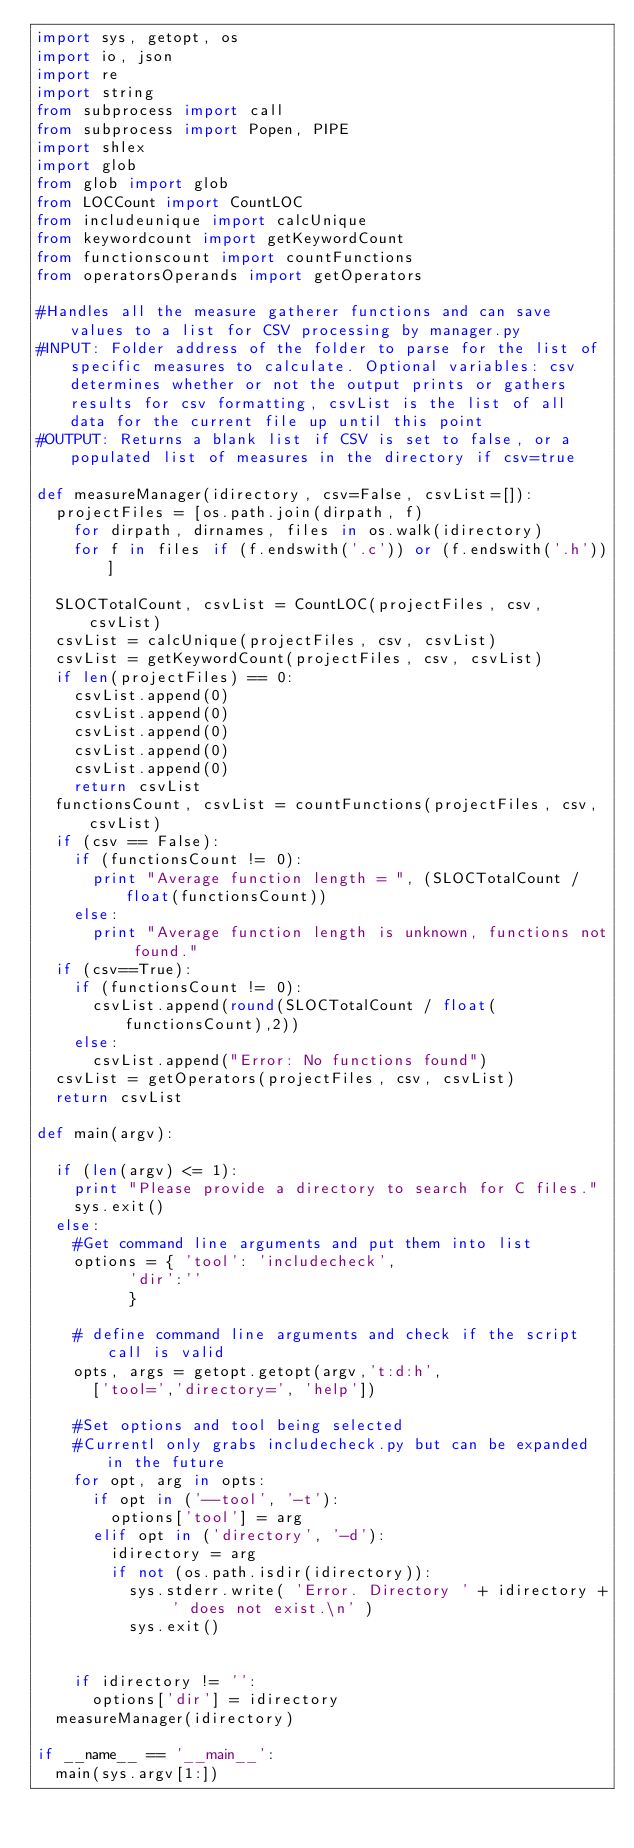Convert code to text. <code><loc_0><loc_0><loc_500><loc_500><_Python_>import sys, getopt, os
import io, json
import re
import string
from subprocess import call
from subprocess import Popen, PIPE
import shlex
import glob
from glob import glob
from LOCCount import CountLOC
from includeunique import calcUnique
from keywordcount import getKeywordCount
from functionscount import countFunctions
from operatorsOperands import getOperators

#Handles all the measure gatherer functions and can save values to a list for CSV processing by manager.py
#INPUT: Folder address of the folder to parse for the list of specific measures to calculate. Optional variables: csv determines whether or not the output prints or gathers results for csv formatting, csvList is the list of all data for the current file up until this point
#OUTPUT: Returns a blank list if CSV is set to false, or a populated list of measures in the directory if csv=true

def measureManager(idirectory, csv=False, csvList=[]):
	projectFiles = [os.path.join(dirpath, f)
		for dirpath, dirnames, files in os.walk(idirectory)
		for f in files if (f.endswith('.c')) or (f.endswith('.h'))]

	SLOCTotalCount, csvList = CountLOC(projectFiles, csv, csvList)
	csvList = calcUnique(projectFiles, csv, csvList)
	csvList = getKeywordCount(projectFiles, csv, csvList)
	if len(projectFiles) == 0:
		csvList.append(0)
		csvList.append(0)
		csvList.append(0)
		csvList.append(0)
		csvList.append(0)
		return csvList
	functionsCount, csvList = countFunctions(projectFiles, csv, csvList)
	if (csv == False):
		if (functionsCount != 0):
			print "Average function length = ", (SLOCTotalCount / float(functionsCount))
		else:
			print "Average function length is unknown, functions not found."
	if (csv==True):
		if (functionsCount != 0):
			csvList.append(round(SLOCTotalCount / float(functionsCount),2))
		else:
			csvList.append("Error: No functions found")
	csvList = getOperators(projectFiles, csv, csvList)
	return csvList

def main(argv):
	
	if (len(argv) <= 1):
		print "Please provide a directory to search for C files."
		sys.exit()
	else:
		#Get command line arguments and put them into list
		options = { 'tool': 'includecheck',
					'dir':''
					}

		# define command line arguments and check if the script call is valid
		opts, args = getopt.getopt(argv,'t:d:h',
			['tool=','directory=', 'help'])
		
		#Set options and tool being selected
		#Currentl only grabs includecheck.py but can be expanded in the future
		for opt, arg in opts:
			if opt in ('--tool', '-t'):
				options['tool'] = arg
			elif opt in ('directory', '-d'):
				idirectory = arg
				if not (os.path.isdir(idirectory)):
					sys.stderr.write( 'Error. Directory ' + idirectory + ' does not exist.\n' )
					sys.exit()


		if idirectory != '':
			options['dir'] = idirectory
	measureManager(idirectory)

if __name__ == '__main__':
	main(sys.argv[1:])</code> 